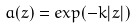Convert formula to latex. <formula><loc_0><loc_0><loc_500><loc_500>a ( z ) = e x p ( - k | z | )</formula> 